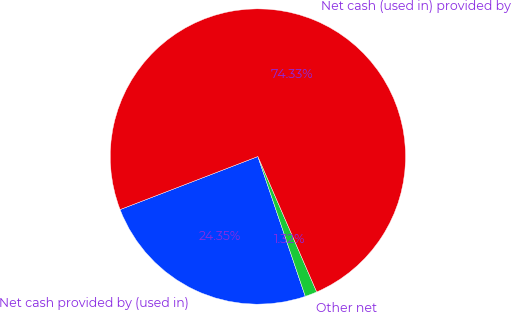Convert chart. <chart><loc_0><loc_0><loc_500><loc_500><pie_chart><fcel>Net cash provided by (used in)<fcel>Other net<fcel>Net cash (used in) provided by<nl><fcel>24.35%<fcel>1.32%<fcel>74.33%<nl></chart> 